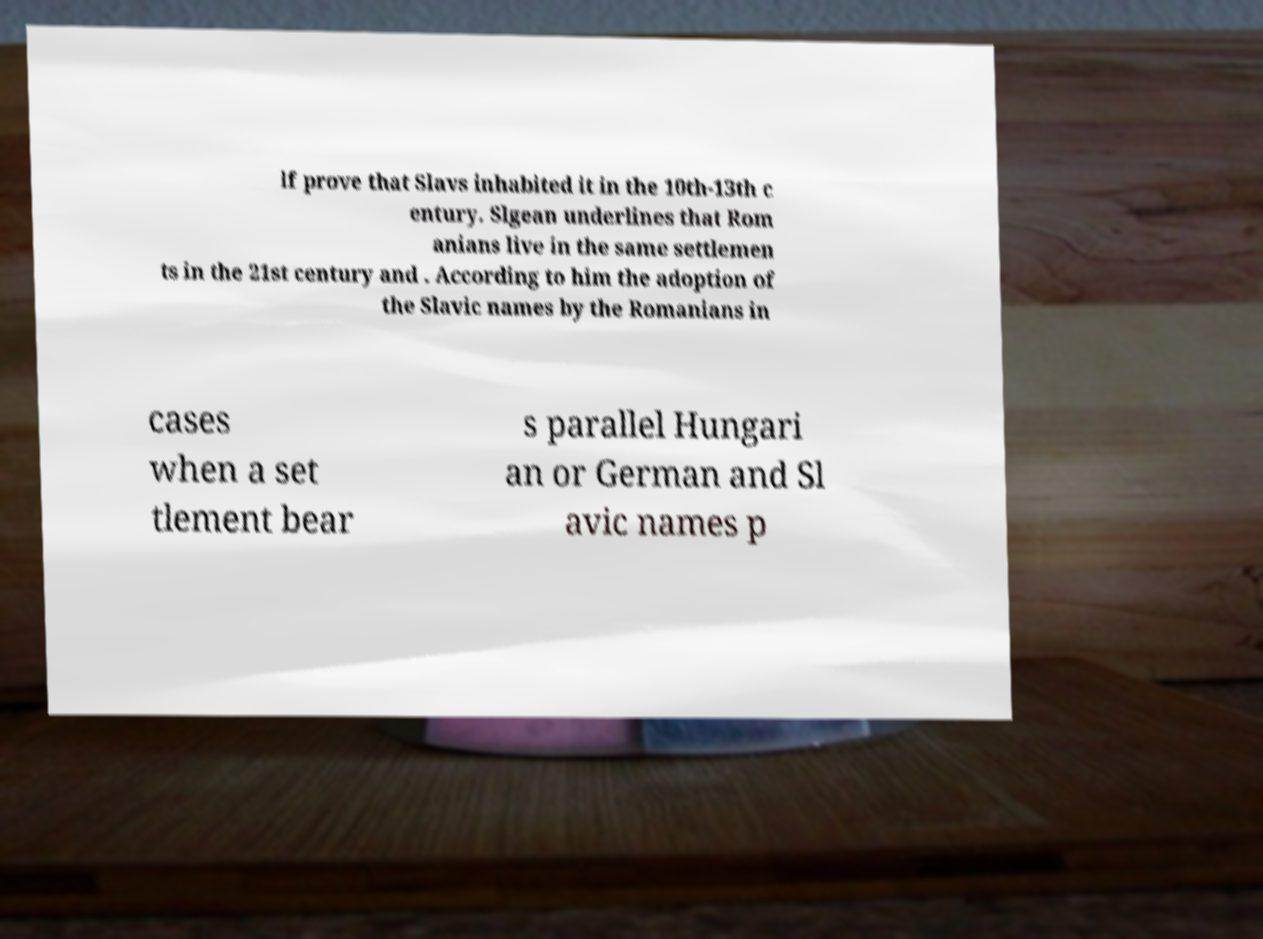There's text embedded in this image that I need extracted. Can you transcribe it verbatim? lf prove that Slavs inhabited it in the 10th-13th c entury. Slgean underlines that Rom anians live in the same settlemen ts in the 21st century and . According to him the adoption of the Slavic names by the Romanians in cases when a set tlement bear s parallel Hungari an or German and Sl avic names p 